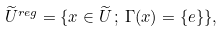Convert formula to latex. <formula><loc_0><loc_0><loc_500><loc_500>\widetilde { U } ^ { r e g } = \{ x \in \widetilde { U } \, ; \, \Gamma ( x ) = \{ e \} \} ,</formula> 